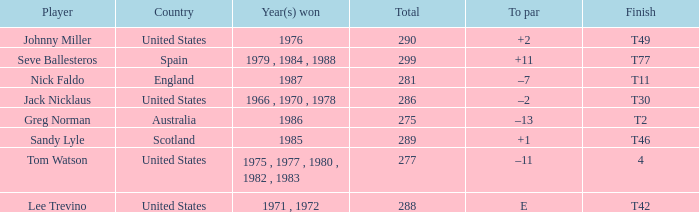Which nation achieved a conclusion of t42? United States. 